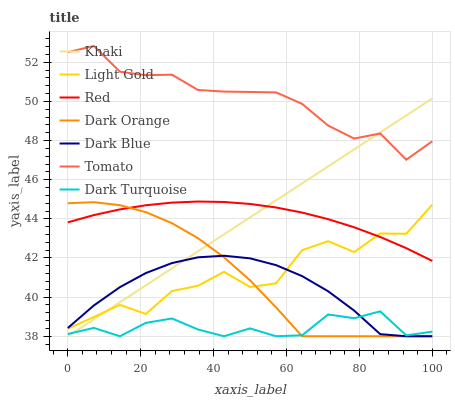Does Dark Orange have the minimum area under the curve?
Answer yes or no. No. Does Dark Orange have the maximum area under the curve?
Answer yes or no. No. Is Dark Orange the smoothest?
Answer yes or no. No. Is Dark Orange the roughest?
Answer yes or no. No. Does Light Gold have the lowest value?
Answer yes or no. No. Does Dark Orange have the highest value?
Answer yes or no. No. Is Dark Blue less than Tomato?
Answer yes or no. Yes. Is Tomato greater than Light Gold?
Answer yes or no. Yes. Does Dark Blue intersect Tomato?
Answer yes or no. No. 